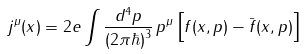<formula> <loc_0><loc_0><loc_500><loc_500>j ^ { \mu } ( x ) = 2 e \int \frac { d ^ { 4 } p } { ( 2 \pi \hbar { ) } ^ { 3 } } \, p ^ { \mu } \left [ f ( x , p ) - \bar { f } ( x , p ) \right ]</formula> 